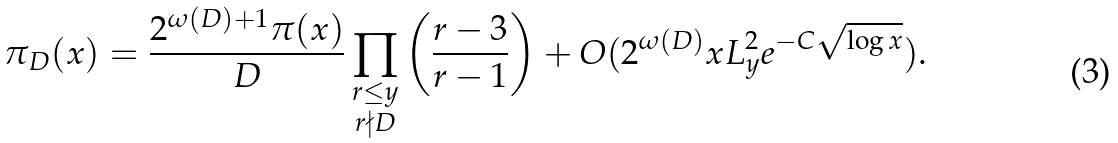Convert formula to latex. <formula><loc_0><loc_0><loc_500><loc_500>\pi _ { D } ( x ) = \frac { 2 ^ { \omega ( D ) + 1 } \pi ( x ) } { D } \prod _ { \substack { r \leq y \\ r \nmid D } } \left ( \frac { r - 3 } { r - 1 } \right ) + O ( 2 ^ { \omega ( D ) } x L _ { y } ^ { 2 } e ^ { - C { \sqrt { \log x } } } ) .</formula> 